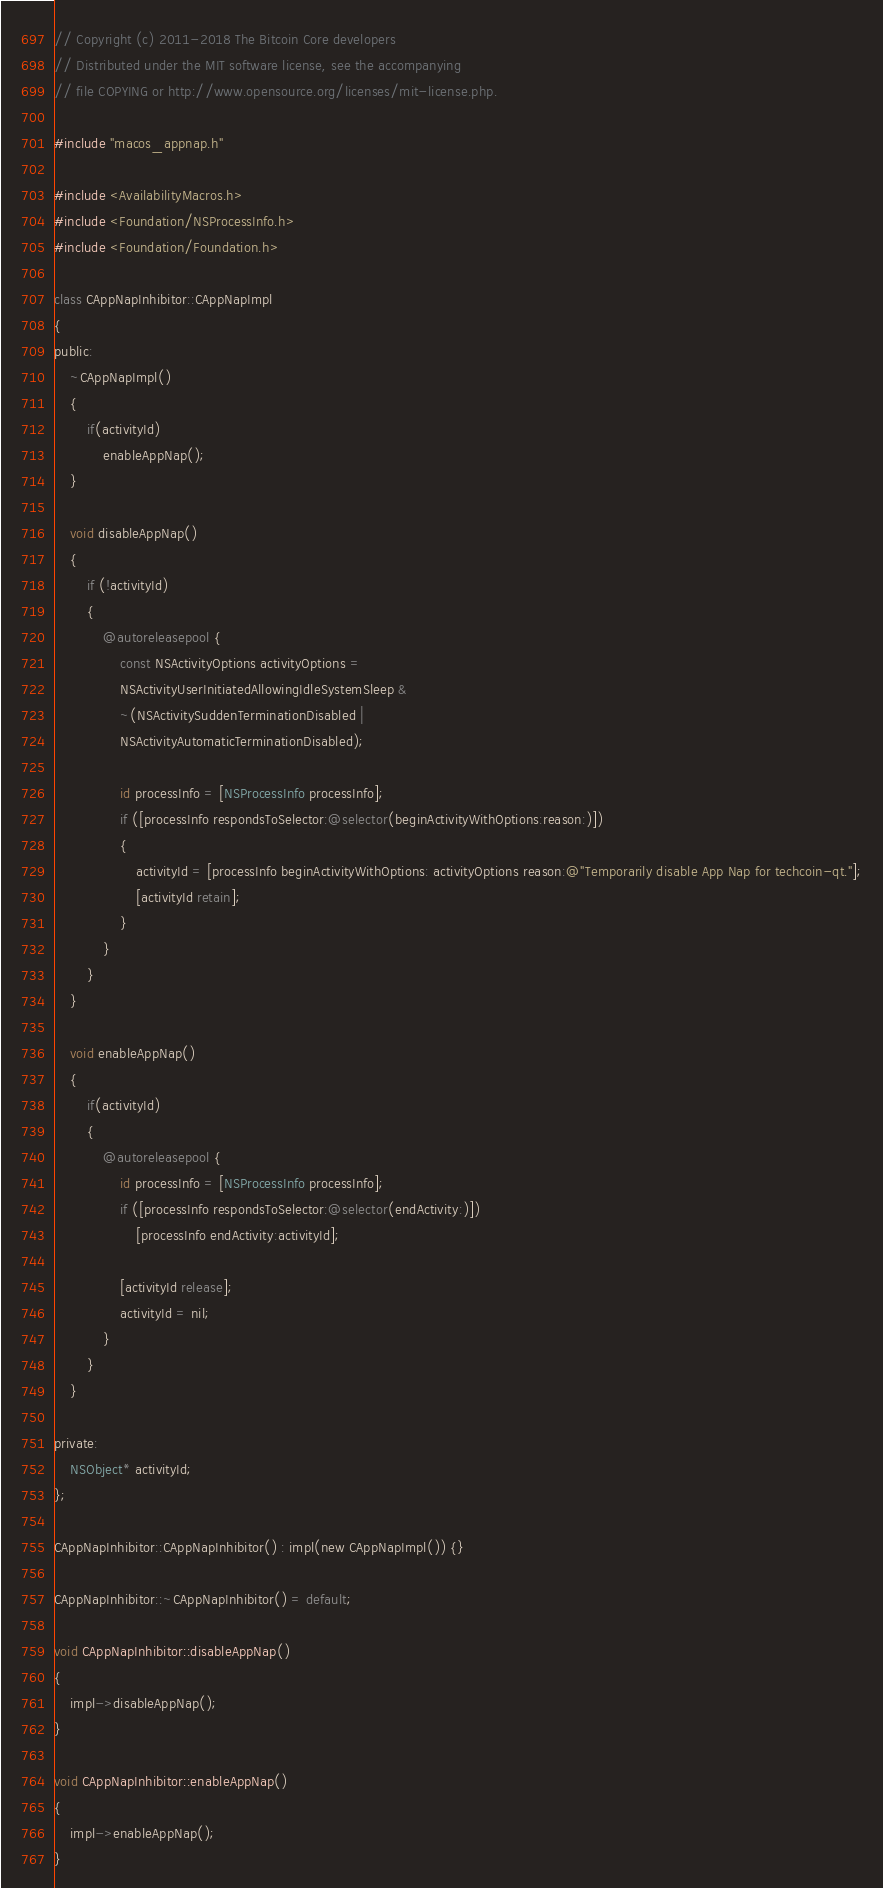<code> <loc_0><loc_0><loc_500><loc_500><_ObjectiveC_>// Copyright (c) 2011-2018 The Bitcoin Core developers
// Distributed under the MIT software license, see the accompanying
// file COPYING or http://www.opensource.org/licenses/mit-license.php.

#include "macos_appnap.h"

#include <AvailabilityMacros.h>
#include <Foundation/NSProcessInfo.h>
#include <Foundation/Foundation.h>

class CAppNapInhibitor::CAppNapImpl
{
public:
    ~CAppNapImpl()
    {
        if(activityId)
            enableAppNap();
    }

    void disableAppNap()
    {
        if (!activityId)
        {
            @autoreleasepool {
                const NSActivityOptions activityOptions =
                NSActivityUserInitiatedAllowingIdleSystemSleep &
                ~(NSActivitySuddenTerminationDisabled |
                NSActivityAutomaticTerminationDisabled);

                id processInfo = [NSProcessInfo processInfo];
                if ([processInfo respondsToSelector:@selector(beginActivityWithOptions:reason:)])
                {
                    activityId = [processInfo beginActivityWithOptions: activityOptions reason:@"Temporarily disable App Nap for techcoin-qt."];
                    [activityId retain];
                }
            }
        }
    }

    void enableAppNap()
    {
        if(activityId)
        {
            @autoreleasepool {
                id processInfo = [NSProcessInfo processInfo];
                if ([processInfo respondsToSelector:@selector(endActivity:)])
                    [processInfo endActivity:activityId];

                [activityId release];
                activityId = nil;
            }
        }
    }

private:
    NSObject* activityId;
};

CAppNapInhibitor::CAppNapInhibitor() : impl(new CAppNapImpl()) {}

CAppNapInhibitor::~CAppNapInhibitor() = default;

void CAppNapInhibitor::disableAppNap()
{
    impl->disableAppNap();
}

void CAppNapInhibitor::enableAppNap()
{
    impl->enableAppNap();
}
</code> 